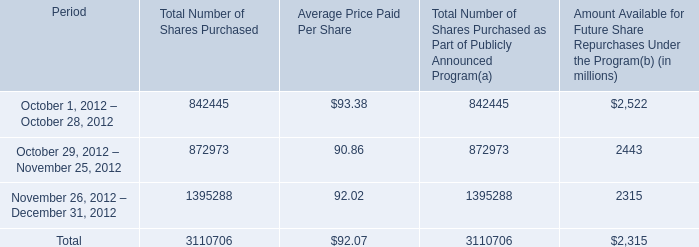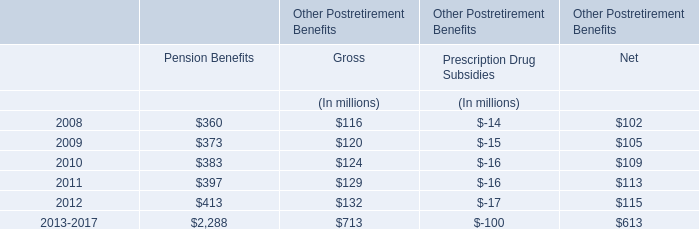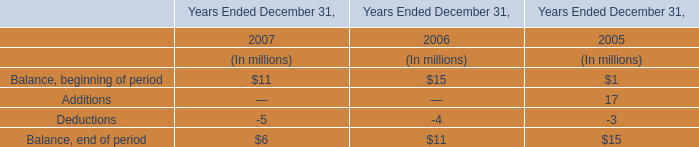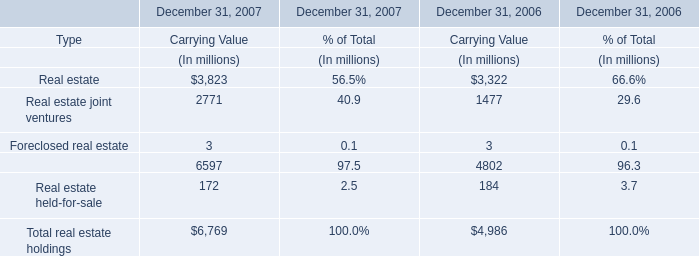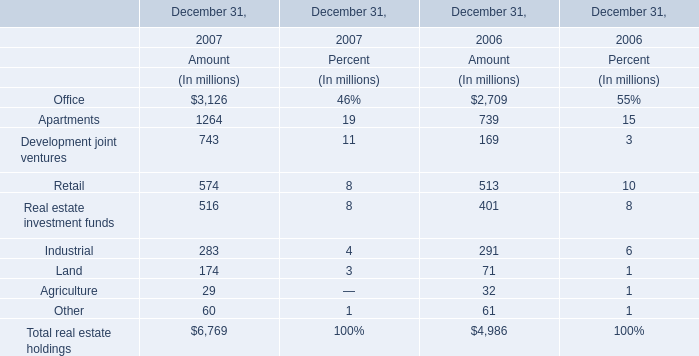what is the total value of repurchased shares during october 2012 , in millions? 
Computations: ((842445 * 93.38) / 1000000)
Answer: 78.66751. 